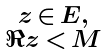Convert formula to latex. <formula><loc_0><loc_0><loc_500><loc_500>\begin{smallmatrix} z \, \in \, E , \\ \Re z \, < \, M \end{smallmatrix}</formula> 